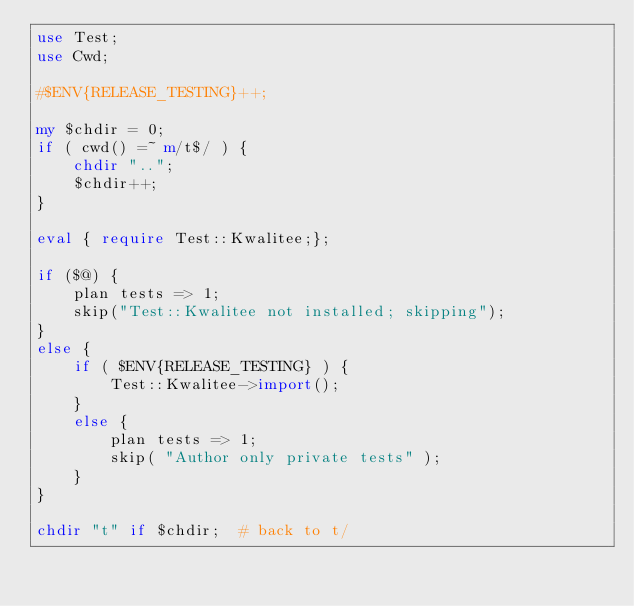Convert code to text. <code><loc_0><loc_0><loc_500><loc_500><_Perl_>use Test;
use Cwd;

#$ENV{RELEASE_TESTING}++;

my $chdir = 0;
if ( cwd() =~ m/t$/ ) {
    chdir "..";
    $chdir++;
}

eval { require Test::Kwalitee;};

if ($@) {
    plan tests => 1;
    skip("Test::Kwalitee not installed; skipping");
}
else {
    if ( $ENV{RELEASE_TESTING} ) {
        Test::Kwalitee->import();
    }
    else {
        plan tests => 1;
        skip( "Author only private tests" );
    }
}

chdir "t" if $chdir;  # back to t/
</code> 